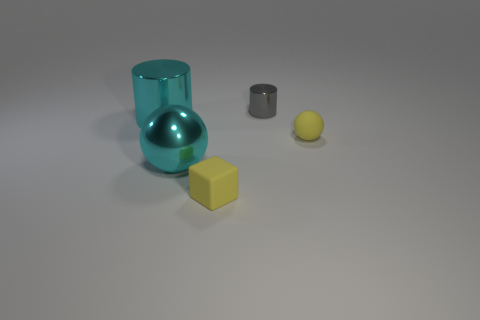Is the big sphere the same color as the big shiny cylinder?
Provide a short and direct response. Yes. There is a big thing that is the same color as the large shiny cylinder; what shape is it?
Offer a very short reply. Sphere. Are there any tiny objects that have the same material as the cube?
Provide a succinct answer. Yes. Is the small gray cylinder made of the same material as the cylinder in front of the tiny gray thing?
Your response must be concise. Yes. There is a cube that is the same size as the yellow ball; what is its color?
Provide a short and direct response. Yellow. What size is the sphere in front of the small yellow thing behind the rubber cube?
Your answer should be very brief. Large. Do the tiny sphere and the small rubber object that is in front of the big ball have the same color?
Your answer should be very brief. Yes. Are there fewer cylinders to the right of the yellow cube than cyan metal spheres?
Provide a short and direct response. No. What number of other objects are there of the same size as the rubber ball?
Offer a terse response. 2. Does the big thing left of the cyan shiny sphere have the same shape as the tiny gray metal object?
Keep it short and to the point. Yes. 